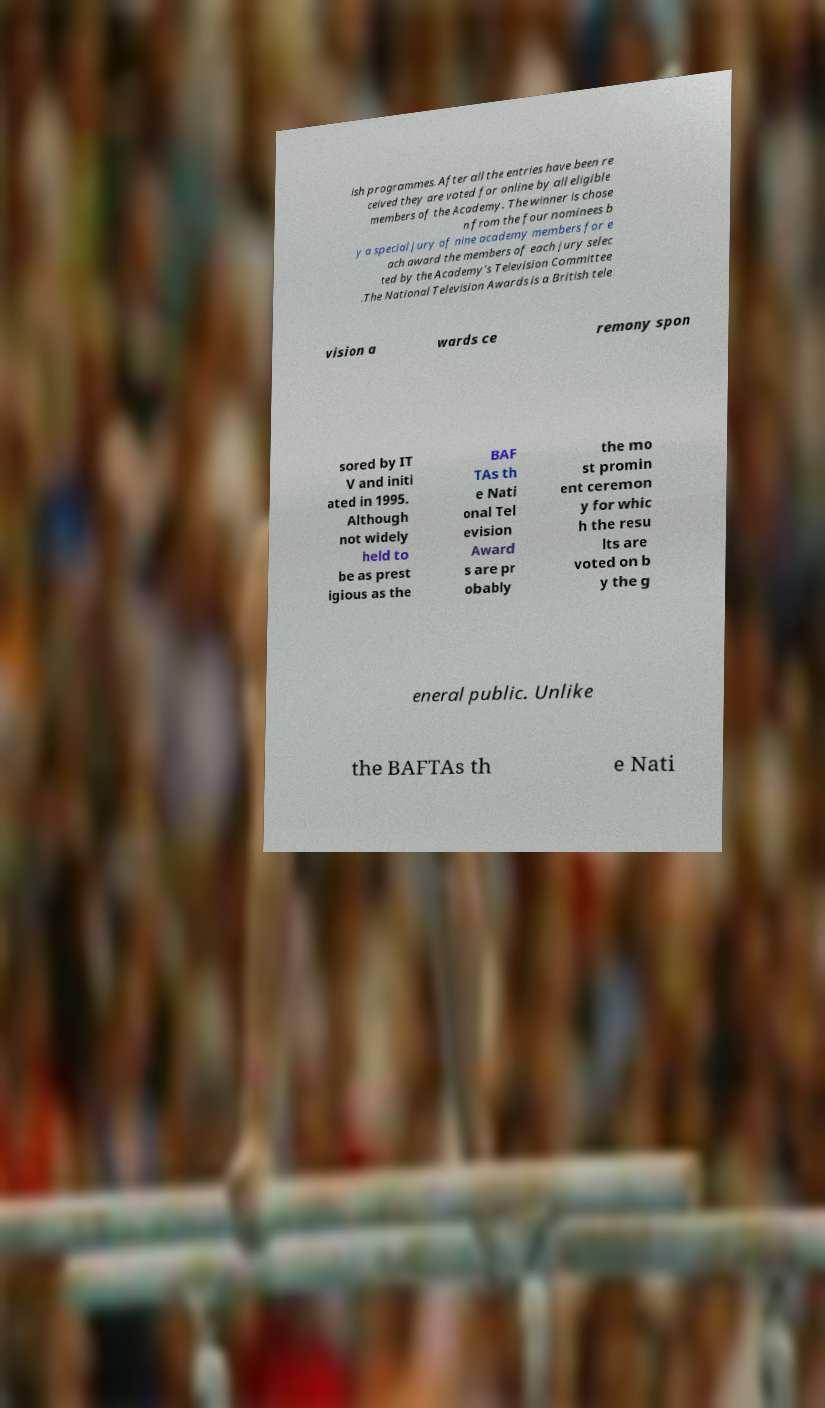Can you accurately transcribe the text from the provided image for me? ish programmes. After all the entries have been re ceived they are voted for online by all eligible members of the Academy. The winner is chose n from the four nominees b y a special jury of nine academy members for e ach award the members of each jury selec ted by the Academy's Television Committee .The National Television Awards is a British tele vision a wards ce remony spon sored by IT V and initi ated in 1995. Although not widely held to be as prest igious as the BAF TAs th e Nati onal Tel evision Award s are pr obably the mo st promin ent ceremon y for whic h the resu lts are voted on b y the g eneral public. Unlike the BAFTAs th e Nati 